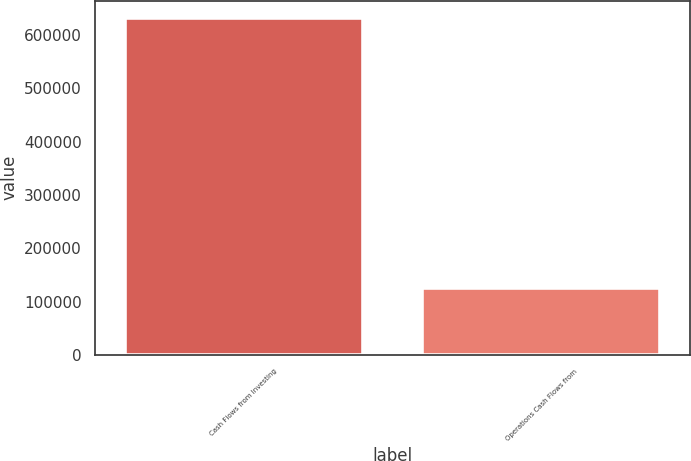<chart> <loc_0><loc_0><loc_500><loc_500><bar_chart><fcel>Cash Flows from Investing<fcel>Operations Cash Flows from<nl><fcel>632703<fcel>125373<nl></chart> 